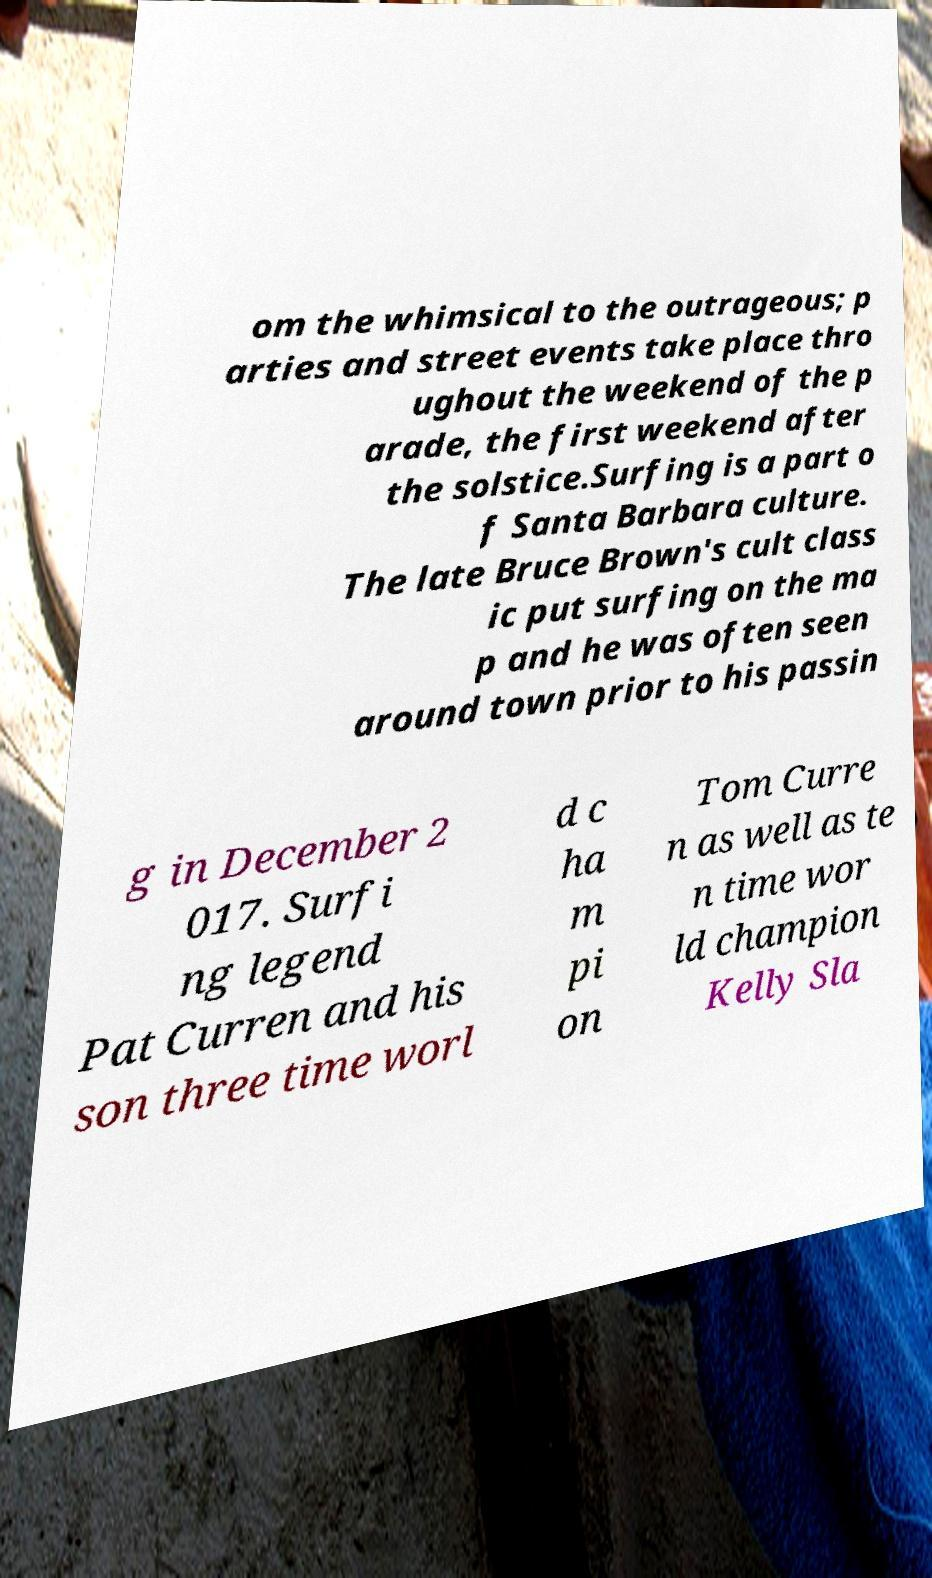Could you extract and type out the text from this image? om the whimsical to the outrageous; p arties and street events take place thro ughout the weekend of the p arade, the first weekend after the solstice.Surfing is a part o f Santa Barbara culture. The late Bruce Brown's cult class ic put surfing on the ma p and he was often seen around town prior to his passin g in December 2 017. Surfi ng legend Pat Curren and his son three time worl d c ha m pi on Tom Curre n as well as te n time wor ld champion Kelly Sla 